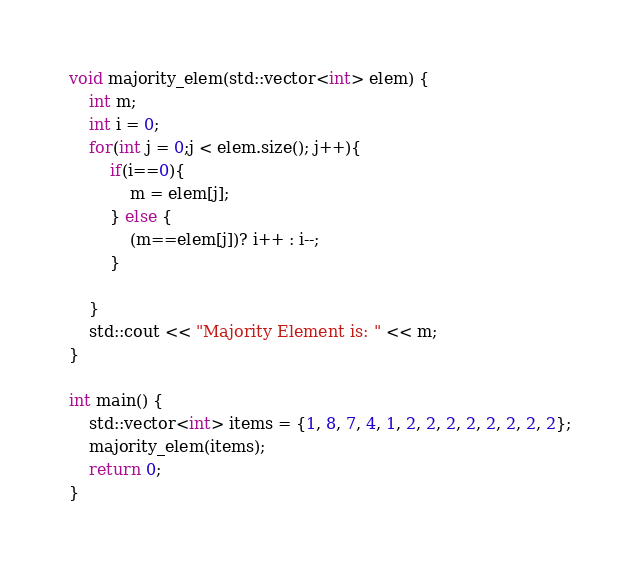Convert code to text. <code><loc_0><loc_0><loc_500><loc_500><_C++_>
void majority_elem(std::vector<int> elem) {
	int m;
	int i = 0;
	for(int j = 0;j < elem.size(); j++){
		if(i==0){
			m = elem[j];
		} else {
			(m==elem[j])? i++ : i--;
		}

	}
	std::cout << "Majority Element is: " << m;
}

int main() {
	std::vector<int> items = {1, 8, 7, 4, 1, 2, 2, 2, 2, 2, 2, 2, 2};
	majority_elem(items);
	return 0;
}</code> 